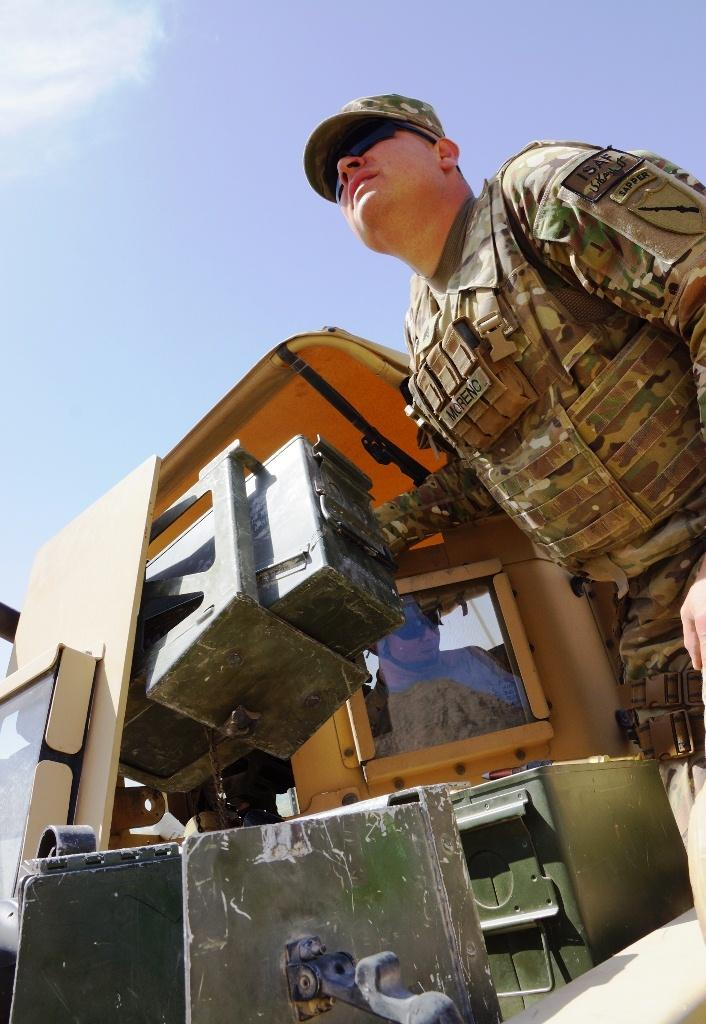What is the main subject of the image? There is a vehicle in the image. Can you describe the person inside the vehicle? There is a person inside the vehicle. What is the person wearing? The person is wearing a military dress. What is the color of the sky in the image? The sky is blue and white in color. How many cats are sitting next to the person wearing a military dress in the image? There are no cats present in the image. What type of prose is being recited by the person inside the vehicle? There is no indication in the image that the person is reciting any prose. 